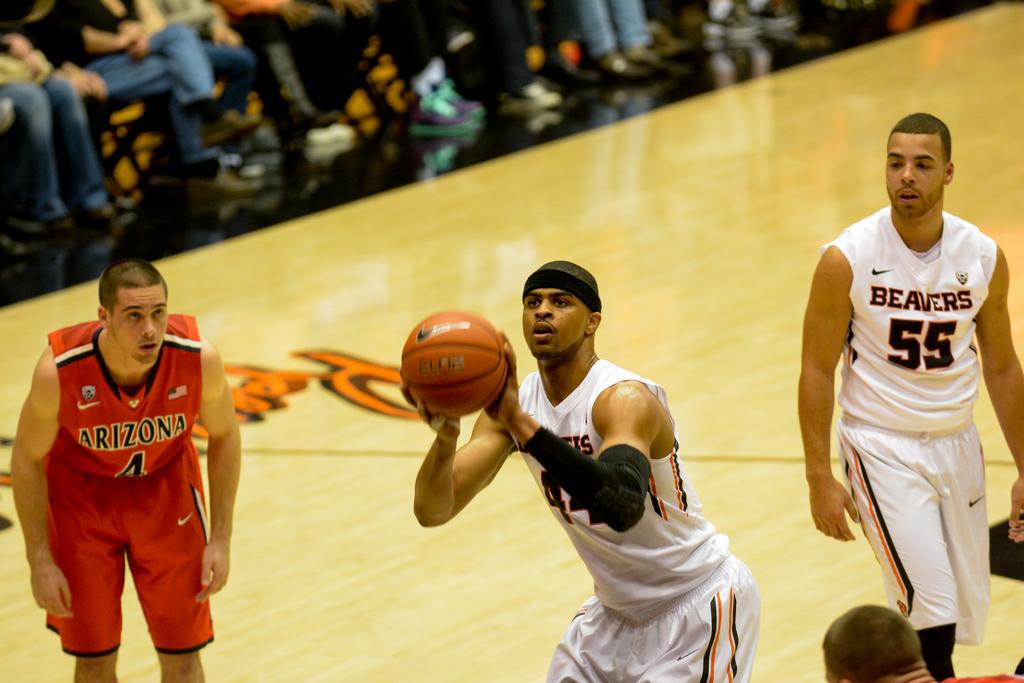What number is the guy on the right?
Keep it short and to the point. 55. 